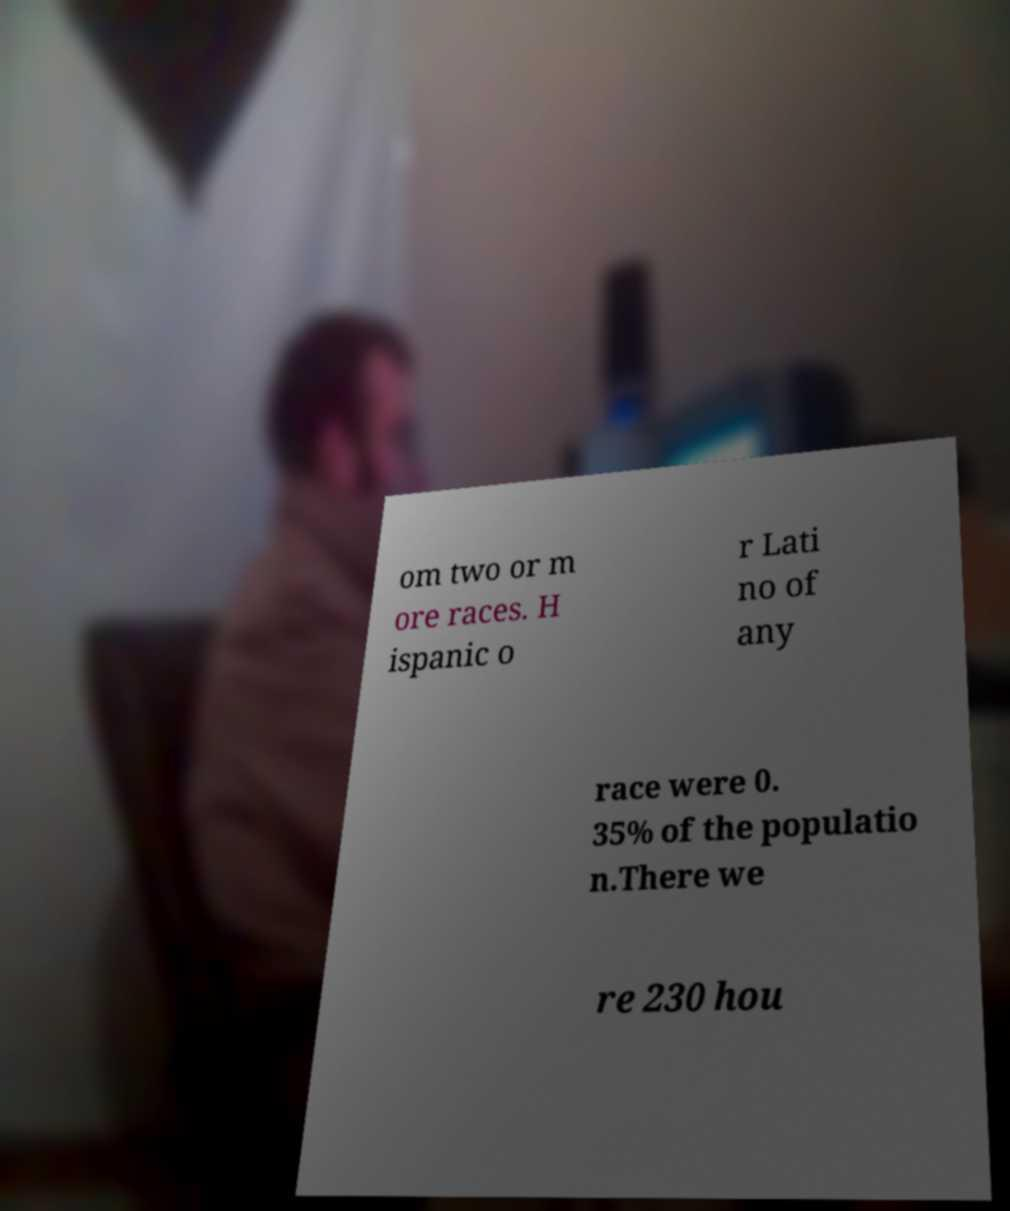Please read and relay the text visible in this image. What does it say? om two or m ore races. H ispanic o r Lati no of any race were 0. 35% of the populatio n.There we re 230 hou 